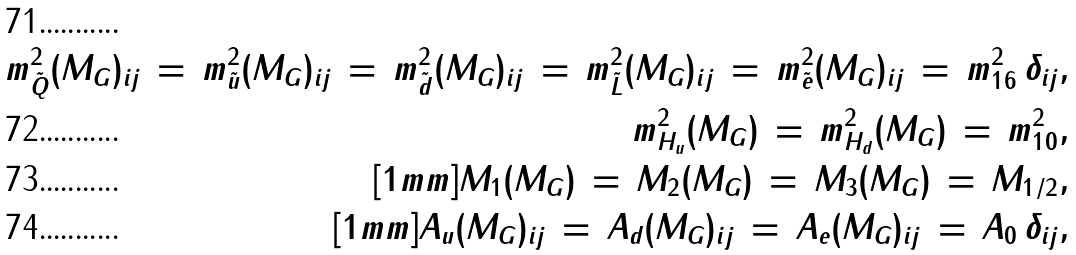<formula> <loc_0><loc_0><loc_500><loc_500>m _ { \tilde { Q } } ^ { 2 } ( M _ { G } ) _ { i j } \, = \, m _ { \tilde { u } } ^ { 2 } ( M _ { G } ) _ { i j } \, = \, m _ { \tilde { d } } ^ { 2 } ( M _ { G } ) _ { i j } \, = \, m _ { \tilde { L } } ^ { 2 } ( M _ { G } ) _ { i j } \, = \, m _ { \tilde { e } } ^ { 2 } ( M _ { G } ) _ { i j } \, = \, m _ { 1 6 } ^ { 2 } \, \delta _ { i j } , \\ m _ { H _ { u } } ^ { 2 } ( M _ { G } ) \, = \, m _ { H _ { d } } ^ { 2 } ( M _ { G } ) \, = \, m _ { 1 0 } ^ { 2 } , \\ [ 1 m m ] M _ { 1 } ( M _ { G } ) \, = \, M _ { 2 } ( M _ { G } ) \, = \, M _ { 3 } ( M _ { G } ) \, = \, M _ { 1 / 2 } , \\ [ 1 m m ] A _ { u } ( M _ { G } ) _ { i j } \, = \, A _ { d } ( M _ { G } ) _ { i j } \, = \, A _ { e } ( M _ { G } ) _ { i j } \, = \, A _ { 0 } \, \delta _ { i j } ,</formula> 